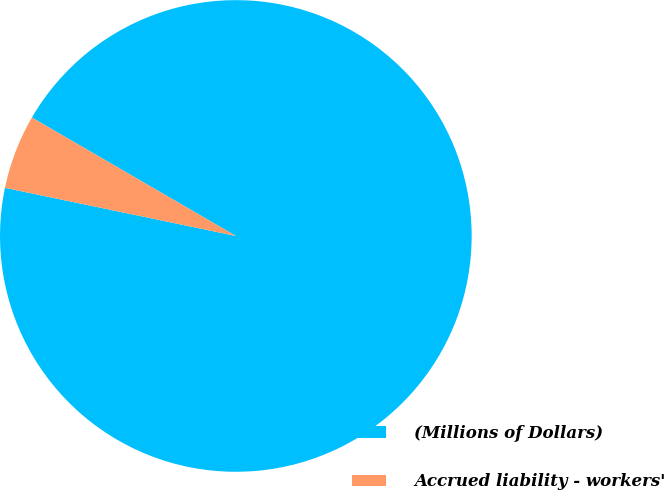Convert chart to OTSL. <chart><loc_0><loc_0><loc_500><loc_500><pie_chart><fcel>(Millions of Dollars)<fcel>Accrued liability - workers'<nl><fcel>94.9%<fcel>5.1%<nl></chart> 